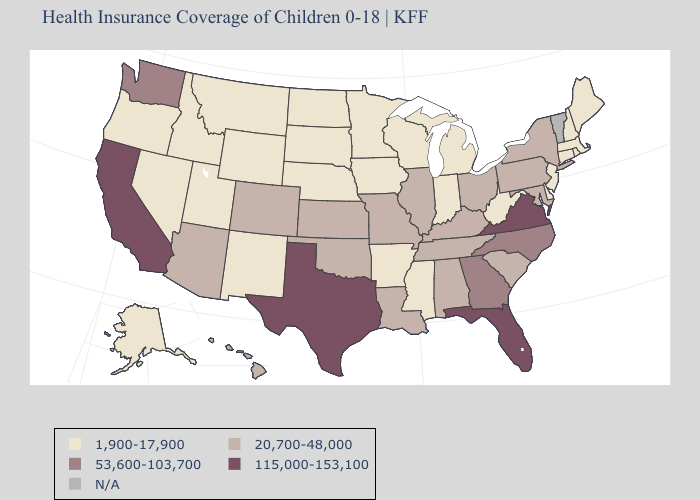What is the value of California?
Give a very brief answer. 115,000-153,100. Name the states that have a value in the range 20,700-48,000?
Answer briefly. Alabama, Arizona, Colorado, Hawaii, Illinois, Kansas, Kentucky, Louisiana, Maryland, Missouri, New York, Ohio, Oklahoma, Pennsylvania, South Carolina, Tennessee. What is the lowest value in states that border New Jersey?
Concise answer only. 1,900-17,900. Name the states that have a value in the range 53,600-103,700?
Give a very brief answer. Georgia, North Carolina, Washington. Does Pennsylvania have the lowest value in the USA?
Short answer required. No. What is the lowest value in states that border Arkansas?
Be succinct. 1,900-17,900. Does Washington have the highest value in the West?
Give a very brief answer. No. What is the value of Wyoming?
Write a very short answer. 1,900-17,900. Among the states that border Arkansas , which have the lowest value?
Keep it brief. Mississippi. Does the first symbol in the legend represent the smallest category?
Write a very short answer. Yes. What is the value of Mississippi?
Give a very brief answer. 1,900-17,900. Among the states that border Maryland , does West Virginia have the lowest value?
Quick response, please. Yes. Does the map have missing data?
Write a very short answer. Yes. What is the highest value in the MidWest ?
Give a very brief answer. 20,700-48,000. 